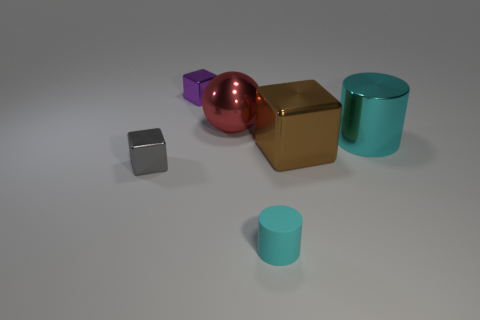Are there any other things that are the same shape as the red metal thing?
Provide a succinct answer. No. What is the material of the big object that is the same color as the tiny cylinder?
Make the answer very short. Metal. Do the small rubber cylinder and the tiny metallic thing left of the tiny purple object have the same color?
Ensure brevity in your answer.  No. Are there more tiny purple objects that are in front of the red thing than tiny gray things that are behind the large cyan object?
Offer a very short reply. No. What shape is the cyan thing that is behind the shiny object left of the block that is behind the large brown thing?
Make the answer very short. Cylinder. What is the shape of the tiny metal thing that is to the left of the tiny shiny block that is behind the big brown block?
Your response must be concise. Cube. Is there a small cyan object that has the same material as the large cyan cylinder?
Provide a succinct answer. No. What is the size of the other cylinder that is the same color as the big cylinder?
Ensure brevity in your answer.  Small. How many yellow things are either cylinders or metal balls?
Provide a short and direct response. 0. Are there any large shiny blocks of the same color as the matte cylinder?
Provide a short and direct response. No. 